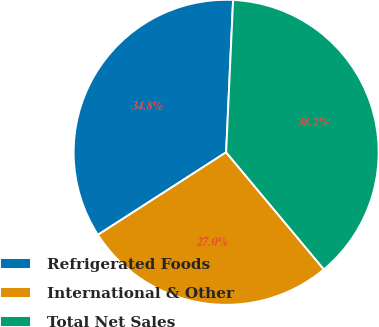Convert chart. <chart><loc_0><loc_0><loc_500><loc_500><pie_chart><fcel>Refrigerated Foods<fcel>International & Other<fcel>Total Net Sales<nl><fcel>34.83%<fcel>26.97%<fcel>38.2%<nl></chart> 